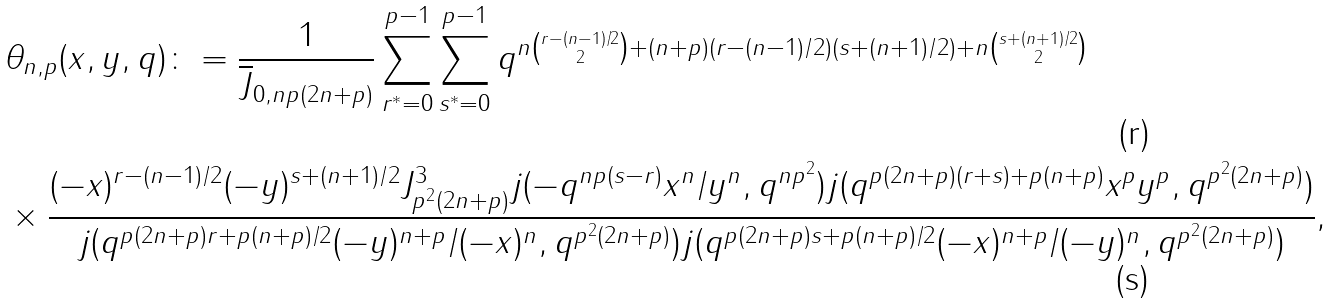<formula> <loc_0><loc_0><loc_500><loc_500>& \theta _ { n , p } ( x , y , q ) \colon = \frac { 1 } { \overline { J } _ { 0 , n p ( 2 n + p ) } } \sum _ { r ^ { * } = 0 } ^ { p - 1 } \sum _ { s ^ { * } = 0 } ^ { p - 1 } q ^ { n \binom { r - ( n - 1 ) / 2 } { 2 } + ( n + p ) ( r - ( n - 1 ) / 2 ) ( s + ( n + 1 ) / 2 ) + n \binom { s + ( n + 1 ) / 2 } { 2 } } \\ & \times \frac { ( - x ) ^ { r - ( n - 1 ) / 2 } ( - y ) ^ { s + ( n + 1 ) / 2 } J _ { p ^ { 2 } ( 2 n + p ) } ^ { 3 } j ( - q ^ { n p ( s - r ) } x ^ { n } / y ^ { n } , q ^ { n p ^ { 2 } } ) j ( q ^ { p ( 2 n + p ) ( r + s ) + p ( n + p ) } x ^ { p } y ^ { p } , q ^ { p ^ { 2 } ( 2 n + p ) } ) } { j ( q ^ { p ( 2 n + p ) r + p ( n + p ) / 2 } ( - y ) ^ { n + p } / ( - x ) ^ { n } , q ^ { p ^ { 2 } ( 2 n + p ) } ) j ( q ^ { p ( 2 n + p ) s + p ( n + p ) / 2 } ( - x ) ^ { n + p } / ( - y ) ^ { n } , q ^ { p ^ { 2 } ( 2 n + p ) } ) } ,</formula> 